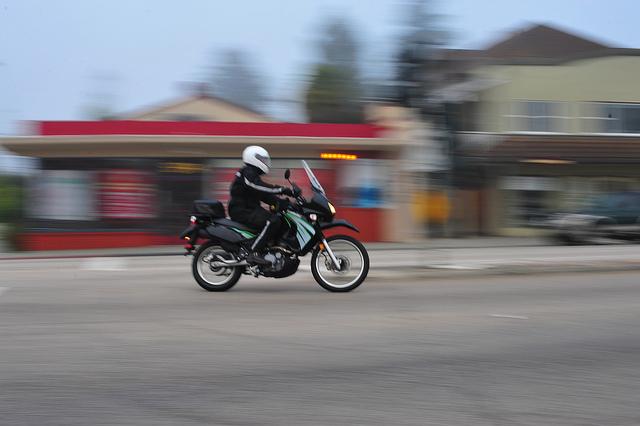Can you see everything clearly?
Write a very short answer. No. Is the rider wearing a helmet?
Concise answer only. Yes. What color is the roof at top of picture?
Concise answer only. Brown. Is the biker racing near a lake?
Write a very short answer. No. What kind of bike is this person riding?
Quick response, please. Motorcycle. How many motorcycles on the road?
Concise answer only. 1. Is it sunny?
Answer briefly. No. 